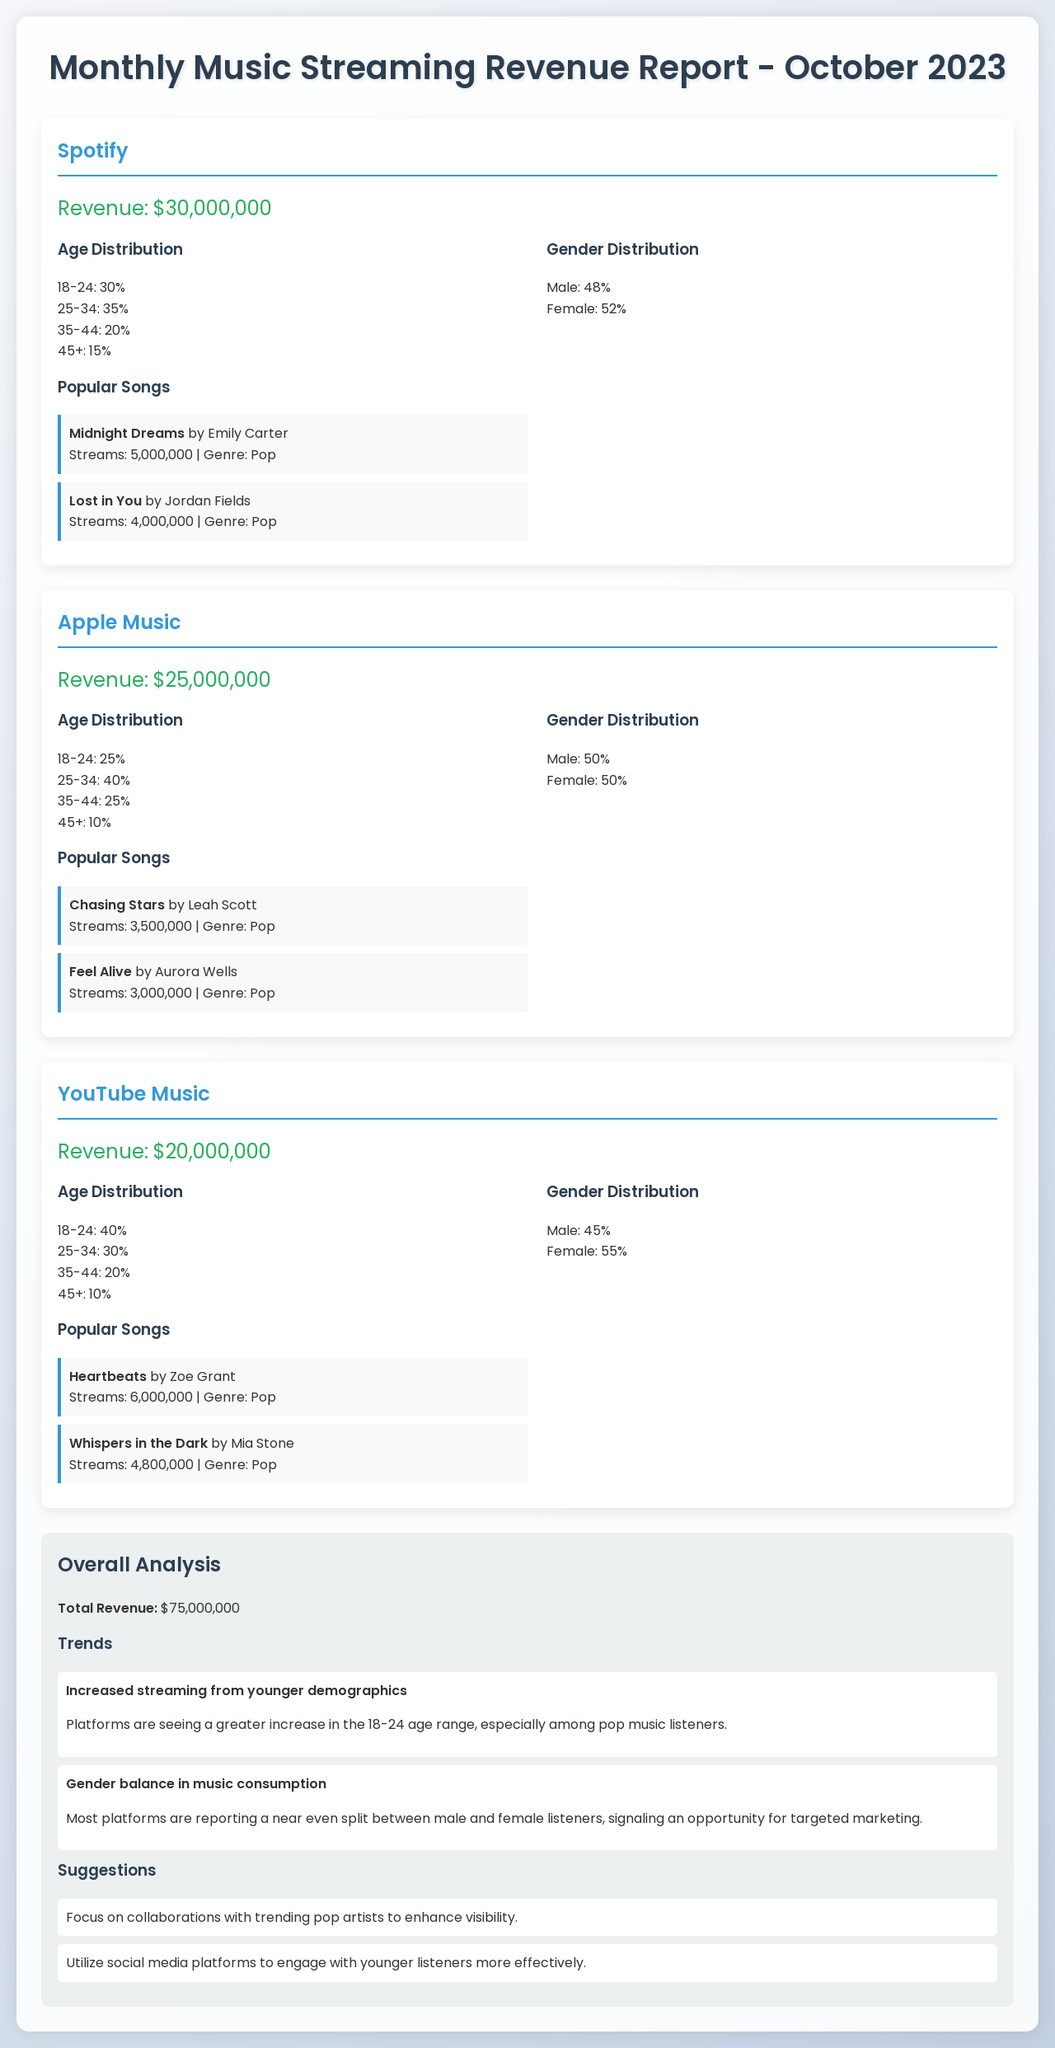what is the revenue from Spotify? The revenue for Spotify is explicitly stated in the document as $30,000,000.
Answer: $30,000,000 which song has the highest streams on YouTube Music? The song with the highest streams on YouTube Music, as per the document, is "Heartbeats" by Zoe Grant with 6,000,000 streams.
Answer: Heartbeats by Zoe Grant what percentage of Spotify listeners are aged 25-34? The document shows that 35% of Spotify listeners are in the 25-34 age range.
Answer: 35% how much revenue does Apple Music generate compared to YouTube Music? The comparison is made by stating Apple Music's revenue ($25,000,000) and YouTube Music's revenue ($20,000,000), leading to a decrease of $5,000,000.
Answer: $5,000,000 what is the age distribution in the 45+ category for YouTube Music? The document indicates that 10% of YouTube Music listeners are aged 45 and above.
Answer: 10% what was the trend regarding gender balance in music consumption? The document states that there is a near even split between male and female listeners across platforms, suggesting marketing opportunities.
Answer: Near even split which platform reports the highest total revenue? The document shows that the total revenue from all platforms is $75,000,000, but does not specify a single platform as highest; Spotify has the highest individual amount.
Answer: Spotify what is a suggested marketing focus mentioned in the overall analysis? The suggested focus in the overall analysis is collaborating with trending pop artists to enhance visibility.
Answer: Collaborations with trending pop artists how many listeners aged 18-24 does Apple Music have? The document states that 25% of Apple Music listeners are aged 18-24.
Answer: 25% 